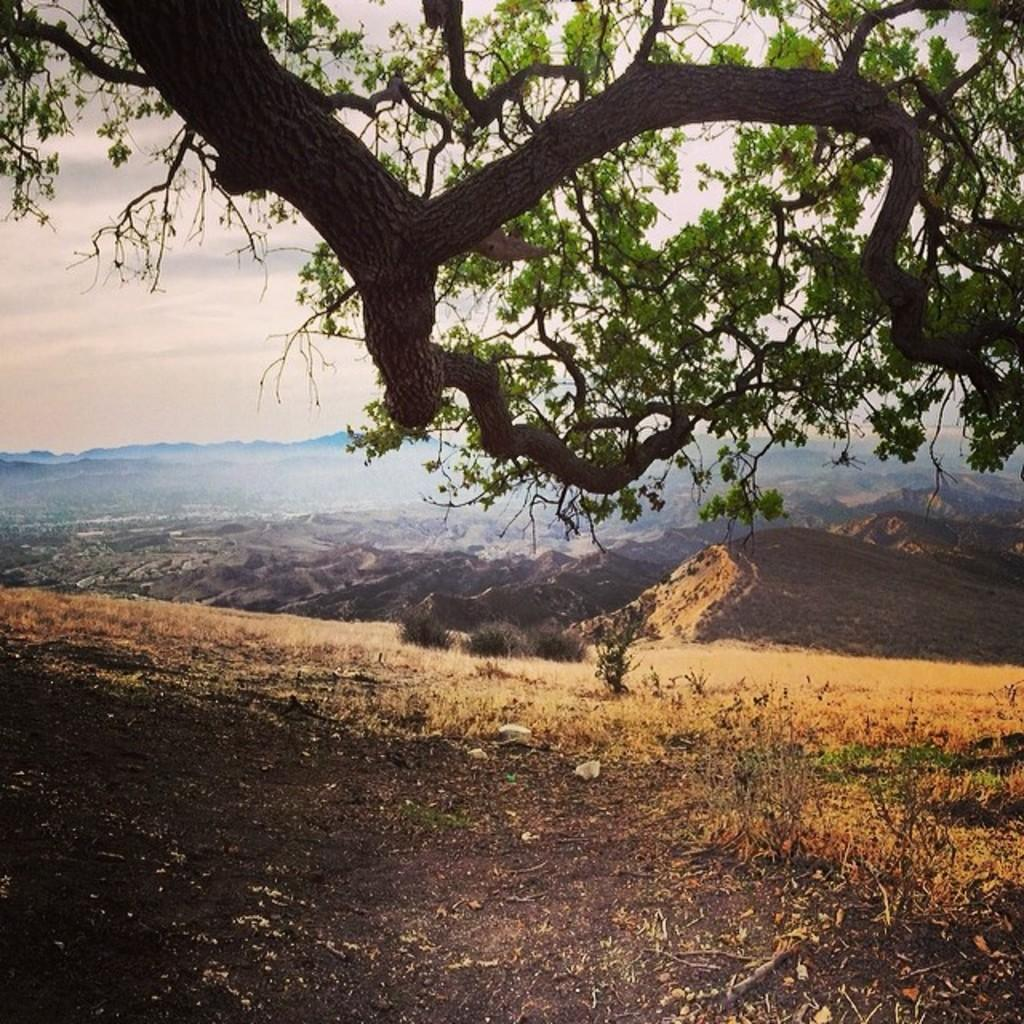What type of vegetation is present in the image? There is a tree in the image. What can be seen in the distance in the image? There are hills visible in the background of the image. How many eggs are on the tree in the image? There are no eggs present on the tree in the image. What type of pencil can be seen being used to draw the hills in the background? There is no pencil or drawing activity depicted in the image. 